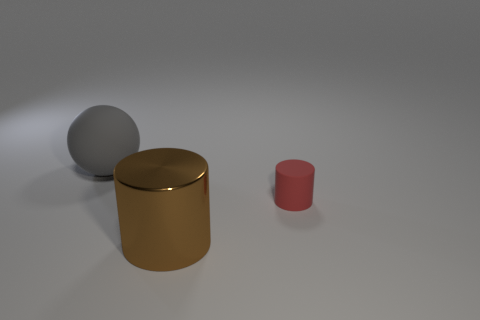Is there any other thing that has the same material as the large brown thing?
Make the answer very short. No. What number of big gray rubber balls are on the left side of the matte thing to the left of the cylinder on the left side of the tiny red object?
Keep it short and to the point. 0. There is a cylinder in front of the tiny red object; what number of rubber things are to the left of it?
Give a very brief answer. 1. There is a gray ball; what number of big brown shiny cylinders are on the right side of it?
Give a very brief answer. 1. How many other things are there of the same size as the brown thing?
Ensure brevity in your answer.  1. What is the size of the red thing that is the same shape as the brown thing?
Give a very brief answer. Small. The rubber thing left of the big brown thing has what shape?
Your answer should be compact. Sphere. What is the color of the cylinder to the right of the large thing to the right of the gray ball?
Make the answer very short. Red. What number of objects are rubber things in front of the big gray matte object or large gray balls?
Keep it short and to the point. 2. There is a brown metallic thing; is it the same size as the object that is left of the big brown metal object?
Give a very brief answer. Yes. 